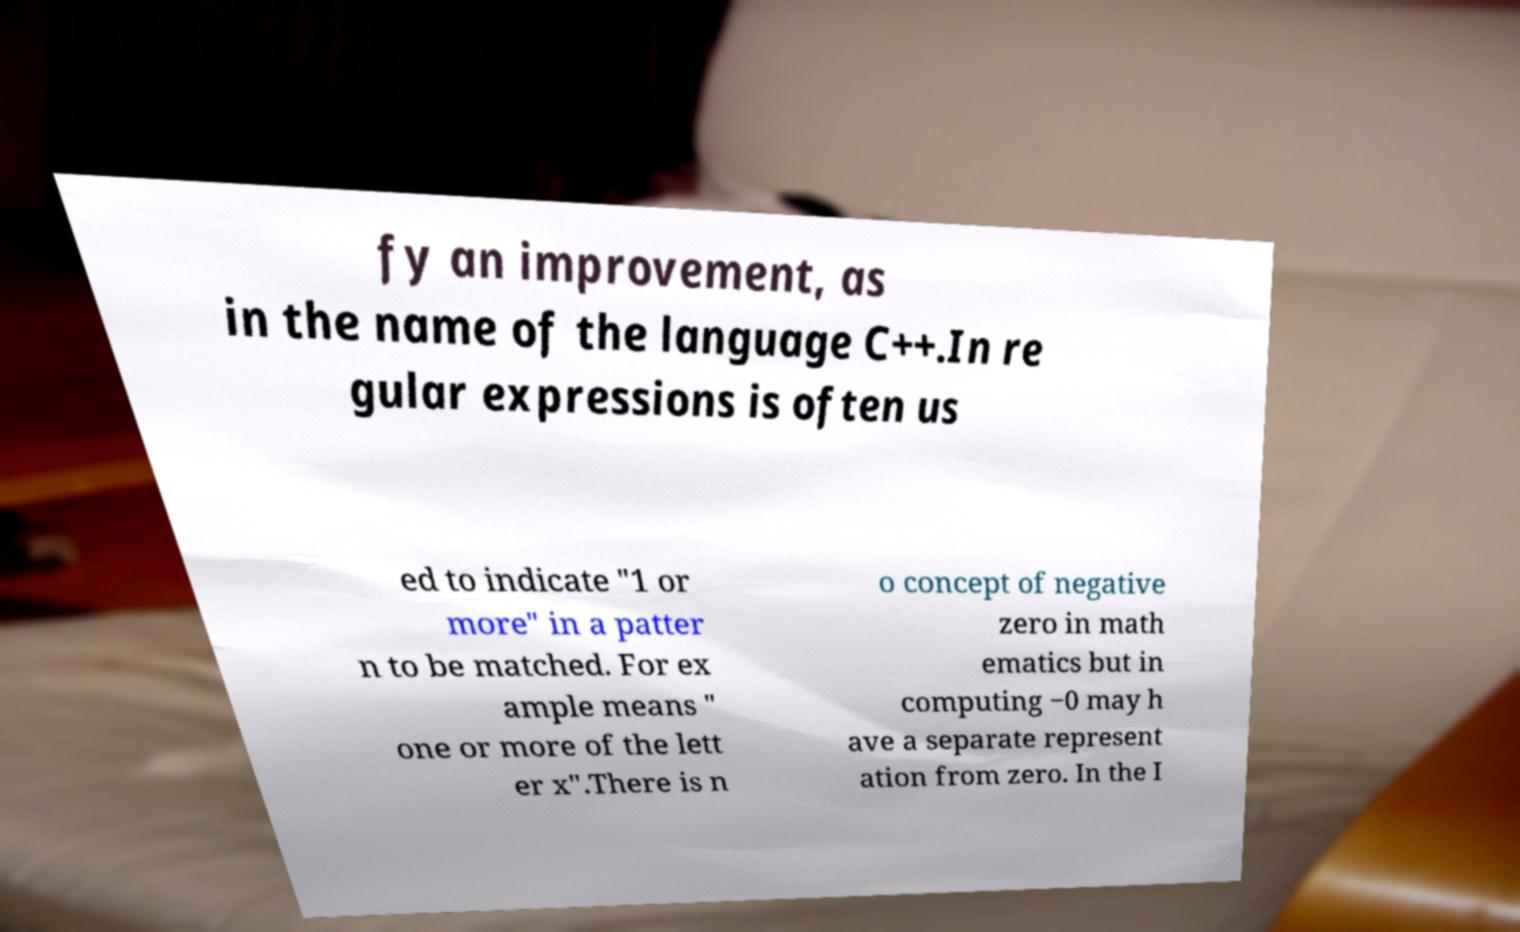There's text embedded in this image that I need extracted. Can you transcribe it verbatim? fy an improvement, as in the name of the language C++.In re gular expressions is often us ed to indicate "1 or more" in a patter n to be matched. For ex ample means " one or more of the lett er x".There is n o concept of negative zero in math ematics but in computing −0 may h ave a separate represent ation from zero. In the I 